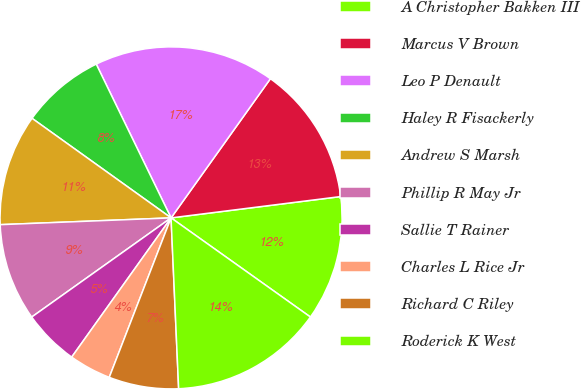Convert chart to OTSL. <chart><loc_0><loc_0><loc_500><loc_500><pie_chart><fcel>A Christopher Bakken III<fcel>Marcus V Brown<fcel>Leo P Denault<fcel>Haley R Fisackerly<fcel>Andrew S Marsh<fcel>Phillip R May Jr<fcel>Sallie T Rainer<fcel>Charles L Rice Jr<fcel>Richard C Riley<fcel>Roderick K West<nl><fcel>11.83%<fcel>13.14%<fcel>17.07%<fcel>7.9%<fcel>10.52%<fcel>9.21%<fcel>5.29%<fcel>3.98%<fcel>6.59%<fcel>14.45%<nl></chart> 